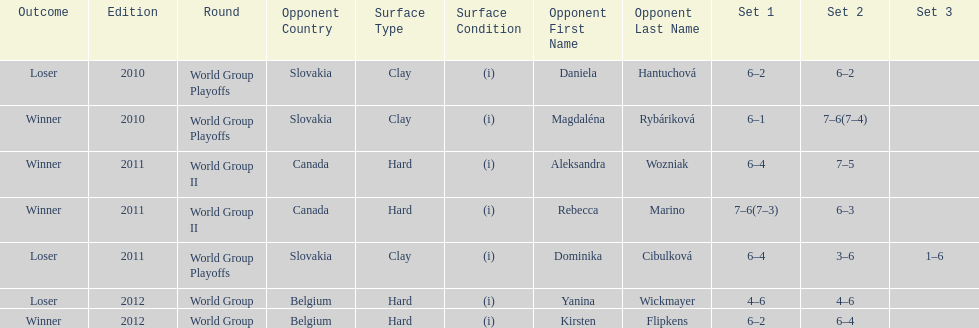Was the game versus canada later than the game versus belgium? No. Write the full table. {'header': ['Outcome', 'Edition', 'Round', 'Opponent Country', 'Surface Type', 'Surface Condition', 'Opponent First Name', 'Opponent Last Name', 'Set 1', 'Set 2', 'Set 3'], 'rows': [['Loser', '2010', 'World Group Playoffs', 'Slovakia', 'Clay', '(i)', 'Daniela', 'Hantuchová', '6–2', '6–2', ''], ['Winner', '2010', 'World Group Playoffs', 'Slovakia', 'Clay', '(i)', 'Magdaléna', 'Rybáriková', '6–1', '7–6(7–4)', ''], ['Winner', '2011', 'World Group II', 'Canada', 'Hard', '(i)', 'Aleksandra', 'Wozniak', '6–4', '7–5', ''], ['Winner', '2011', 'World Group II', 'Canada', 'Hard', '(i)', 'Rebecca', 'Marino', '7–6(7–3)', '6–3', ''], ['Loser', '2011', 'World Group Playoffs', 'Slovakia', 'Clay', '(i)', 'Dominika', 'Cibulková', '6–4', '3–6', '1–6'], ['Loser', '2012', 'World Group', 'Belgium', 'Hard', '(i)', 'Yanina', 'Wickmayer', '4–6', '4–6', ''], ['Winner', '2012', 'World Group', 'Belgium', 'Hard', '(i)', 'Kirsten', 'Flipkens', '6–2', '6–4', '']]} 